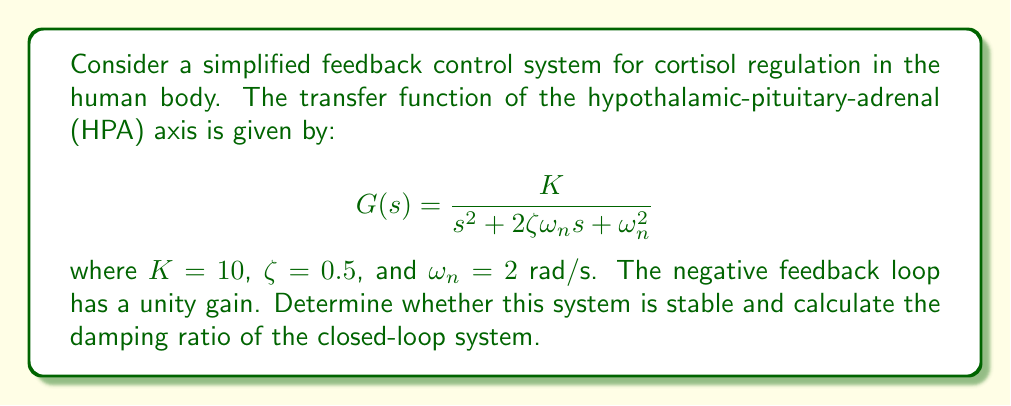What is the answer to this math problem? To analyze the stability of this feedback control system, we need to follow these steps:

1. Determine the closed-loop transfer function.
2. Find the characteristic equation.
3. Apply the Routh-Hurwitz stability criterion.
4. Calculate the closed-loop damping ratio.

Step 1: Closed-loop transfer function

The closed-loop transfer function is given by:

$$T(s) = \frac{G(s)}{1 + G(s)}$$

Substituting the given $G(s)$:

$$T(s) = \frac{\frac{10}{s^2 + 2s + 4}}{1 + \frac{10}{s^2 + 2s + 4}}$$

Step 2: Characteristic equation

The characteristic equation is the denominator of $T(s)$ set to zero:

$$1 + \frac{10}{s^2 + 2s + 4} = 0$$

Multiplying both sides by $(s^2 + 2s + 4)$:

$$s^2 + 2s + 4 + 10 = 0$$
$$s^2 + 2s + 14 = 0$$

Step 3: Routh-Hurwitz stability criterion

For a second-order system $as^2 + bs + c = 0$, the system is stable if $a > 0$, $b > 0$, and $c > 0$.

In our case, $a = 1 > 0$, $b = 2 > 0$, and $c = 14 > 0$. Therefore, the system is stable.

Step 4: Closed-loop damping ratio

The standard form of a second-order characteristic equation is:

$$s^2 + 2\zeta_{cl}\omega_{n,cl}s + \omega_{n,cl}^2 = 0$$

Comparing this with our characteristic equation:

$$s^2 + 2s + 14 = 0$$

We can identify that:

$$2\zeta_{cl}\omega_{n,cl} = 2$$
$$\omega_{n,cl}^2 = 14$$

Solving for $\omega_{n,cl}$:

$$\omega_{n,cl} = \sqrt{14} \approx 3.74 \text{ rad/s}$$

Now we can solve for $\zeta_{cl}$:

$$\zeta_{cl} = \frac{2}{2\omega_{n,cl}} = \frac{1}{\sqrt{14}} \approx 0.267$$
Answer: The system is stable. The closed-loop damping ratio is $\zeta_{cl} = \frac{1}{\sqrt{14}} \approx 0.267$. 